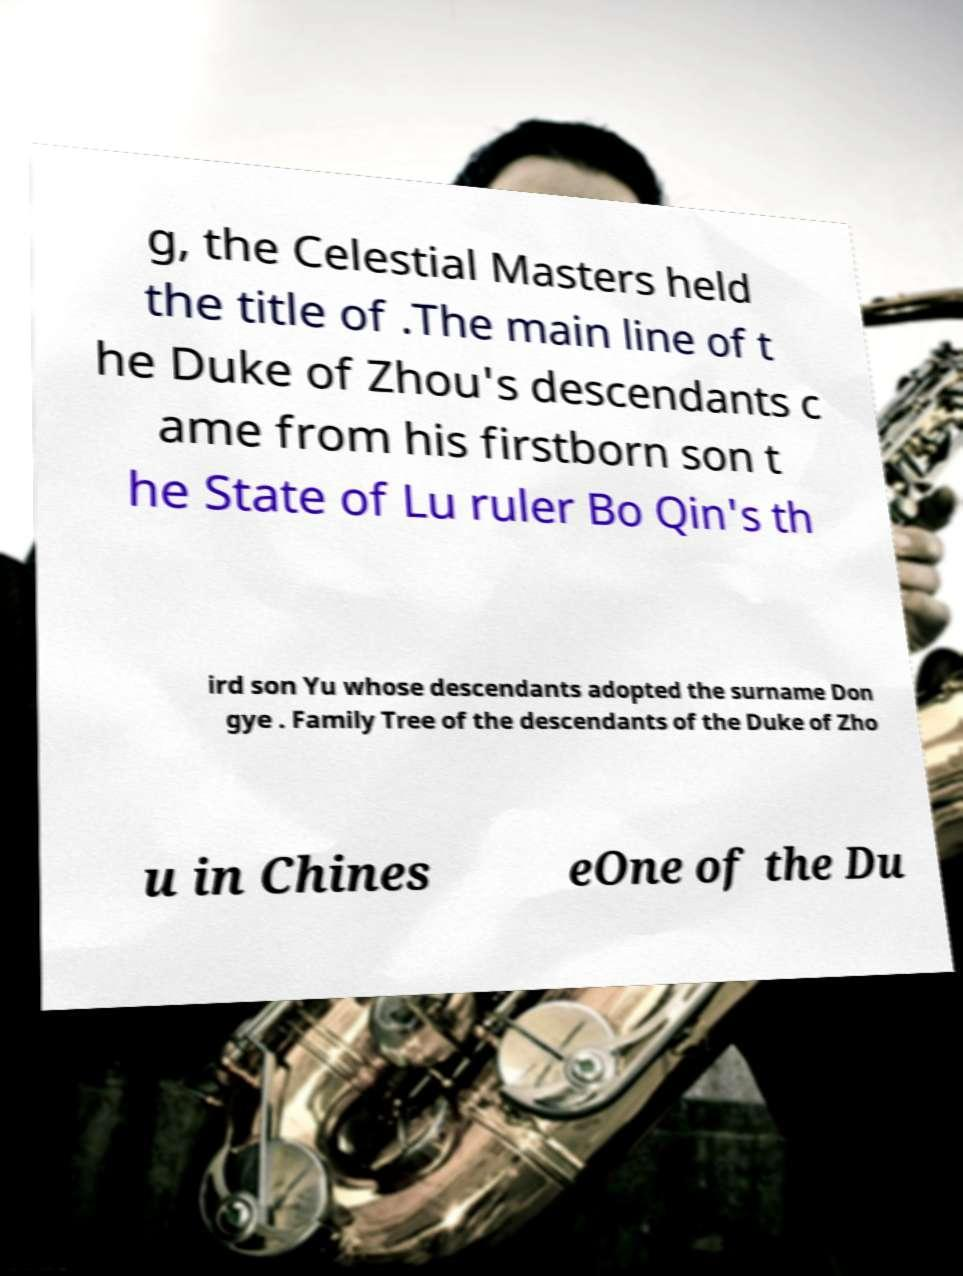Could you assist in decoding the text presented in this image and type it out clearly? g, the Celestial Masters held the title of .The main line of t he Duke of Zhou's descendants c ame from his firstborn son t he State of Lu ruler Bo Qin's th ird son Yu whose descendants adopted the surname Don gye . Family Tree of the descendants of the Duke of Zho u in Chines eOne of the Du 